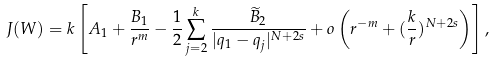Convert formula to latex. <formula><loc_0><loc_0><loc_500><loc_500>J ( W ) = k \left [ A _ { 1 } + \frac { B _ { 1 } } { r ^ { m } } - \frac { 1 } { 2 } \sum _ { j = 2 } ^ { k } \frac { \widetilde { B } _ { 2 } } { | q _ { 1 } - q _ { j } | ^ { N + 2 s } } + o \left ( r ^ { - m } + ( \frac { k } { r } ) ^ { N + 2 s } \right ) \right ] ,</formula> 